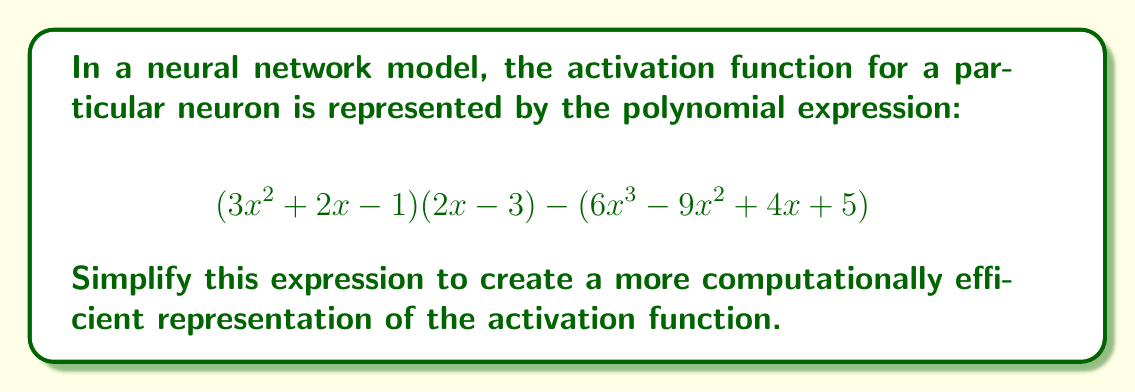Show me your answer to this math problem. Let's simplify this expression step-by-step:

1) First, let's expand $(3x^2 + 2x - 1)(2x - 3)$:
   $$(3x^2 + 2x - 1)(2x - 3) = 6x^3 - 9x^2 + 4x^2 - 6x - 2x + 3$$
   $$= 6x^3 - 5x^2 - 8x + 3$$

2) Now our expression looks like:
   $$(6x^3 - 5x^2 - 8x + 3) - (6x^3 - 9x^2 + 4x + 5)$$

3) Let's subtract the second polynomial from the first:
   $$6x^3 - 5x^2 - 8x + 3$$
   $$- (6x^3 - 9x^2 + 4x + 5)$$

4) Subtracting term by term:
   $$6x^3 - 6x^3 = 0$$
   $$-5x^2 - (-9x^2) = 4x^2$$
   $$-8x - 4x = -12x$$
   $$3 - 5 = -2$$

5) Combining the results:
   $$4x^2 - 12x - 2$$

This simplified polynomial represents a more computationally efficient form of the activation function.
Answer: $4x^2 - 12x - 2$ 